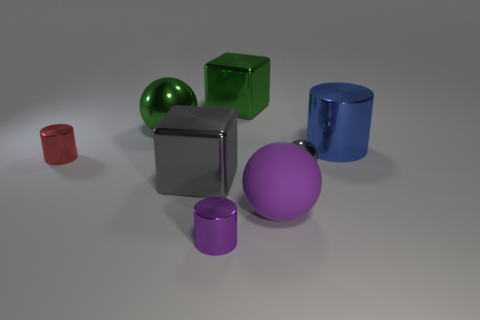What color is the large block behind the big thing right of the large ball right of the green cube?
Offer a very short reply. Green. Is the number of tiny purple metallic cylinders greater than the number of yellow shiny spheres?
Provide a short and direct response. Yes. How many large objects are in front of the red metal object and on the right side of the large gray metallic thing?
Provide a succinct answer. 1. What number of spheres are to the right of the small shiny thing in front of the big purple object?
Offer a very short reply. 2. There is a block that is to the right of the purple metal cylinder; is its size the same as the purple thing that is right of the green metallic cube?
Offer a terse response. Yes. How many big green things are there?
Your answer should be very brief. 2. What number of tiny yellow balls have the same material as the gray sphere?
Ensure brevity in your answer.  0. Are there the same number of cylinders behind the small purple thing and small gray objects?
Give a very brief answer. No. What is the material of the tiny cylinder that is the same color as the large rubber thing?
Provide a succinct answer. Metal. Do the green ball and the gray object that is to the left of the tiny purple cylinder have the same size?
Your answer should be very brief. Yes. 